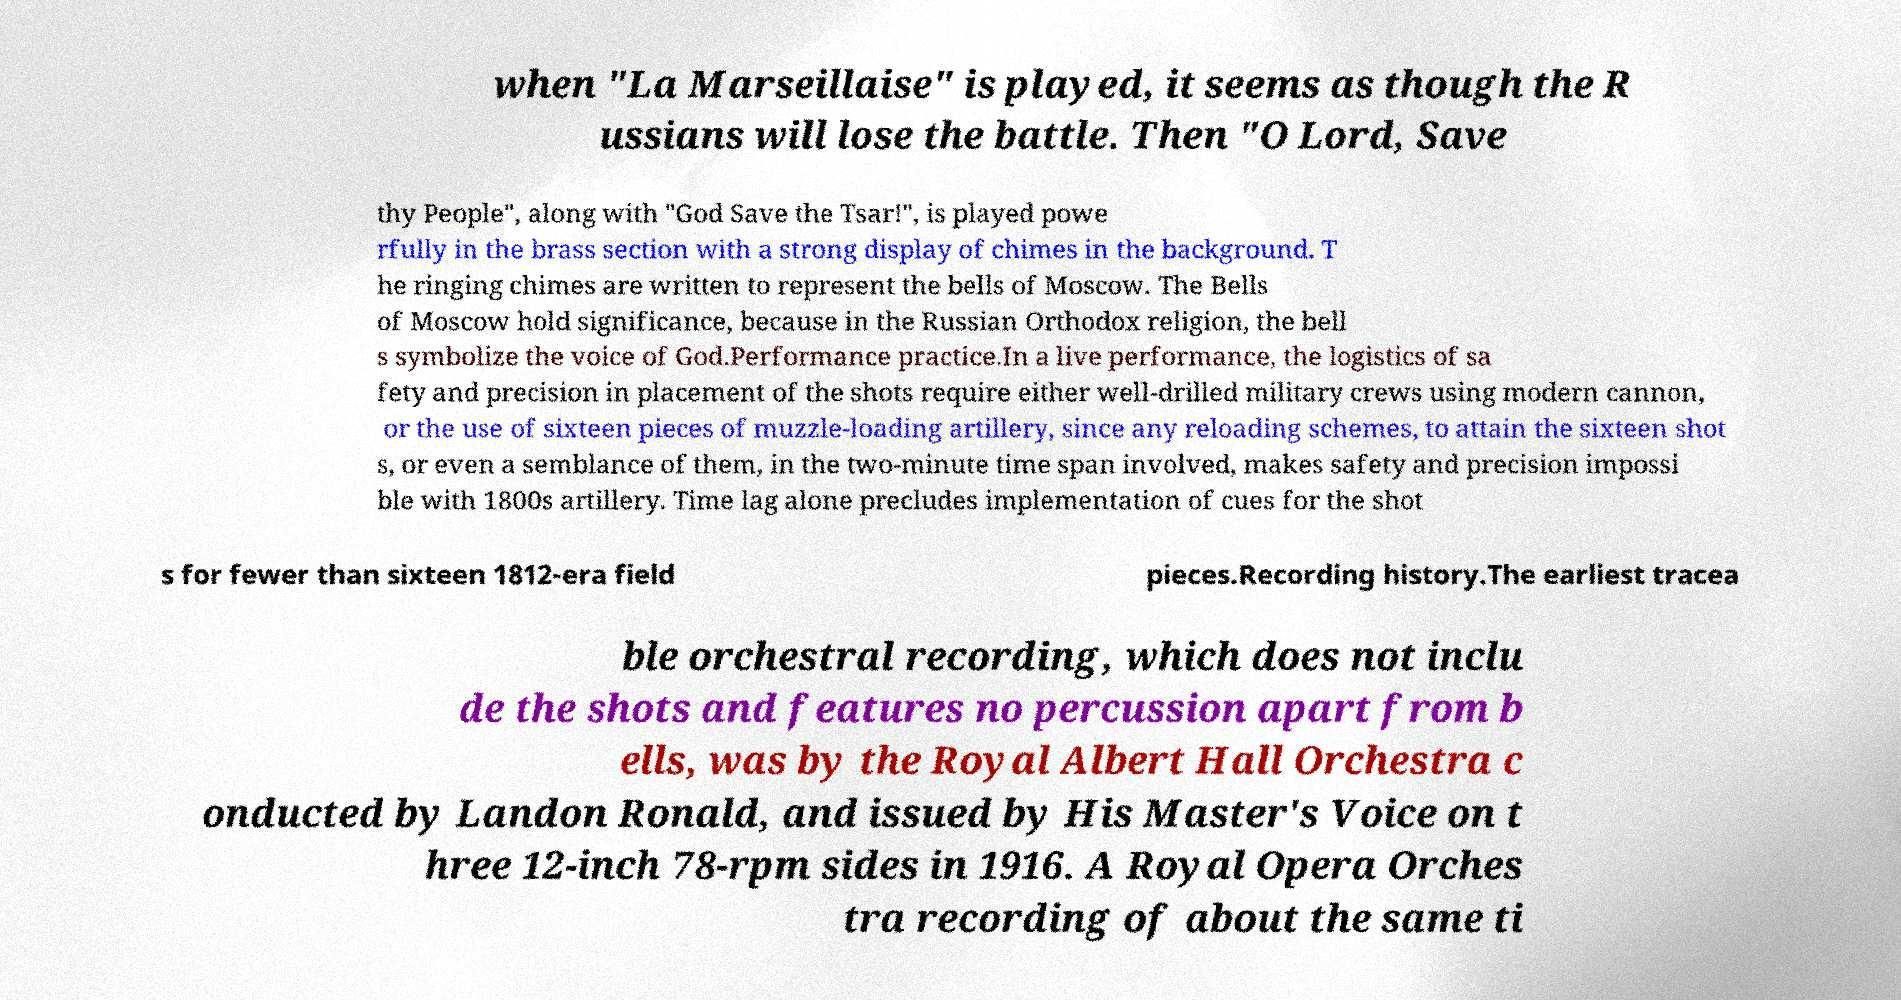What messages or text are displayed in this image? I need them in a readable, typed format. when "La Marseillaise" is played, it seems as though the R ussians will lose the battle. Then "O Lord, Save thy People", along with "God Save the Tsar!", is played powe rfully in the brass section with a strong display of chimes in the background. T he ringing chimes are written to represent the bells of Moscow. The Bells of Moscow hold significance, because in the Russian Orthodox religion, the bell s symbolize the voice of God.Performance practice.In a live performance, the logistics of sa fety and precision in placement of the shots require either well-drilled military crews using modern cannon, or the use of sixteen pieces of muzzle-loading artillery, since any reloading schemes, to attain the sixteen shot s, or even a semblance of them, in the two-minute time span involved, makes safety and precision impossi ble with 1800s artillery. Time lag alone precludes implementation of cues for the shot s for fewer than sixteen 1812-era field pieces.Recording history.The earliest tracea ble orchestral recording, which does not inclu de the shots and features no percussion apart from b ells, was by the Royal Albert Hall Orchestra c onducted by Landon Ronald, and issued by His Master's Voice on t hree 12-inch 78-rpm sides in 1916. A Royal Opera Orches tra recording of about the same ti 